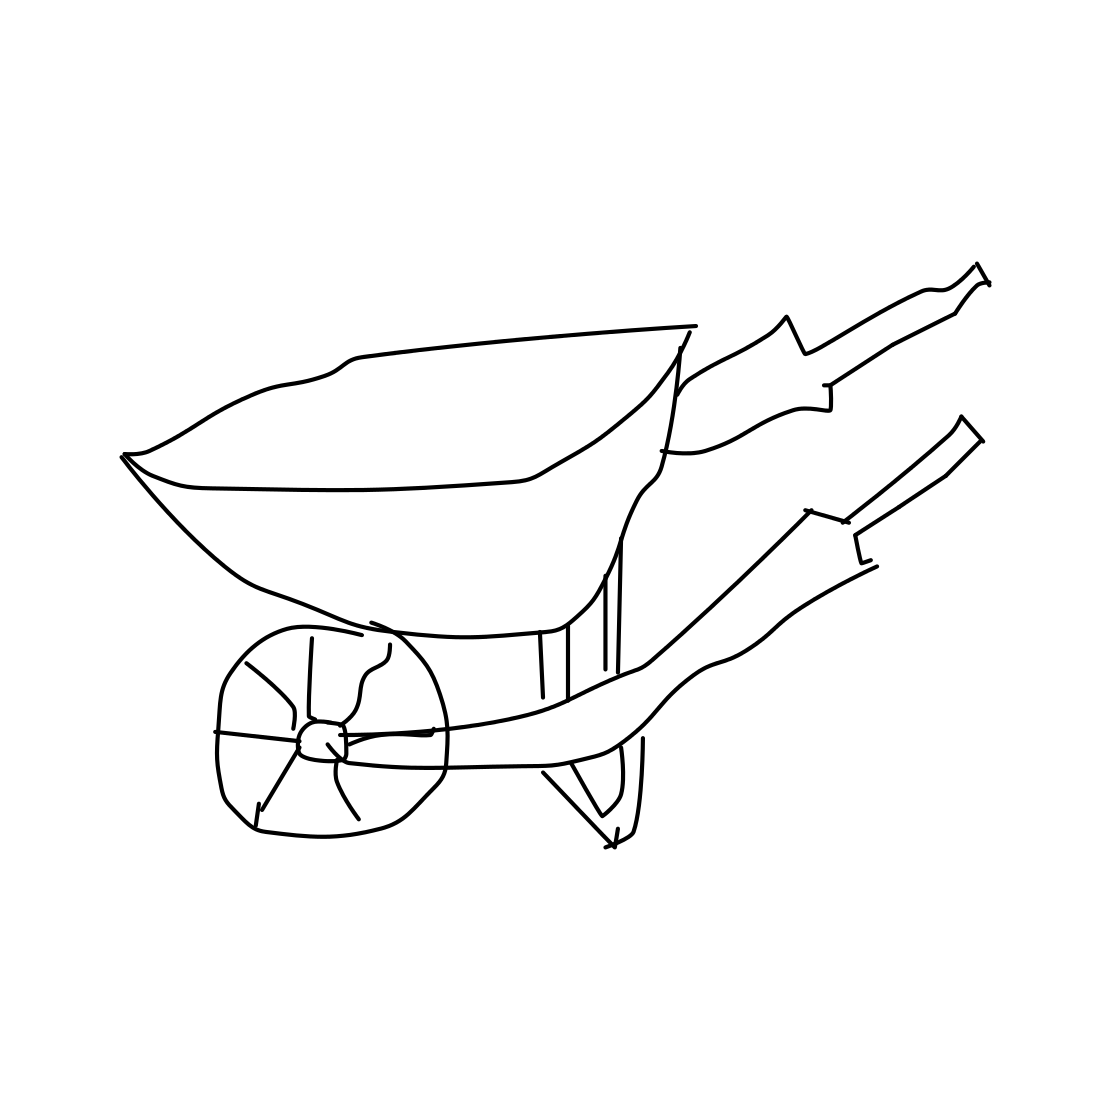Is this design of wheelbarrow suitable for all types of terrain? This wheelbarrow design with a single wheel works best on solid, even ground, where precise control is needed. However, it might be more challenging to use on very soft or uneven terrain, like a sandy beach or a rocky landscape, where a two-wheeled model might offer more stability and ease of use.  Could this wheelbarrow be used by people of all strengths? In general, wheelbarrows are designed to leverage the user's strength effectively, but they do require some physical effort, especially when fully loaded. People with less strength might find it tough to handle a heavy wheelbarrow, but for light gardening tasks, it's suitable for a wide range of users. 